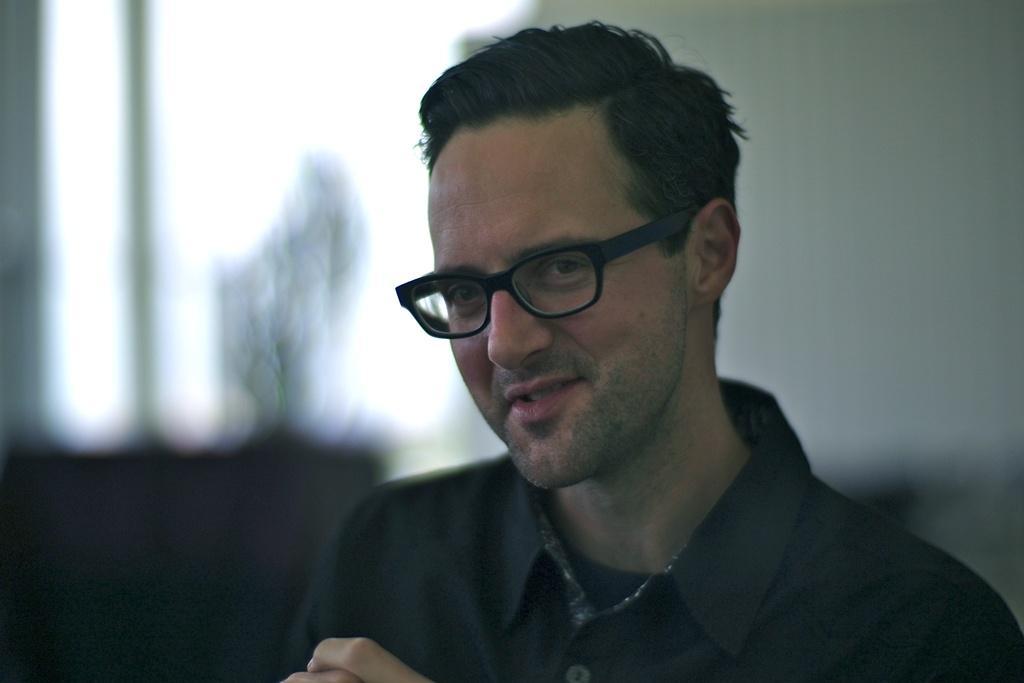Could you give a brief overview of what you see in this image? In this image we can see a man and he is wearing one shirt and glasses. 